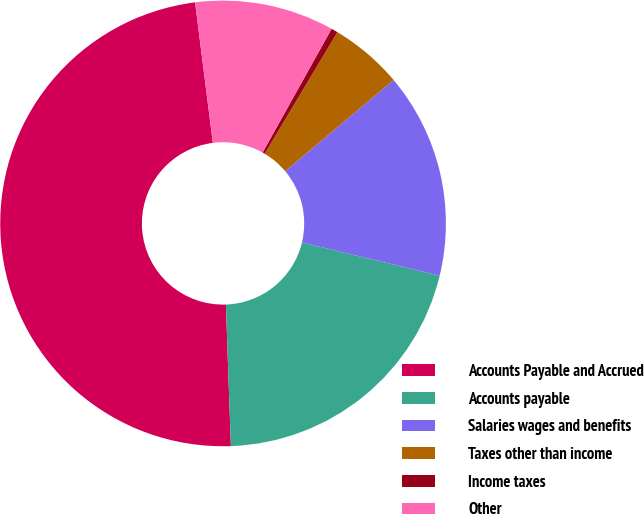Convert chart. <chart><loc_0><loc_0><loc_500><loc_500><pie_chart><fcel>Accounts Payable and Accrued<fcel>Accounts payable<fcel>Salaries wages and benefits<fcel>Taxes other than income<fcel>Income taxes<fcel>Other<nl><fcel>48.55%<fcel>20.67%<fcel>14.9%<fcel>5.29%<fcel>0.48%<fcel>10.1%<nl></chart> 